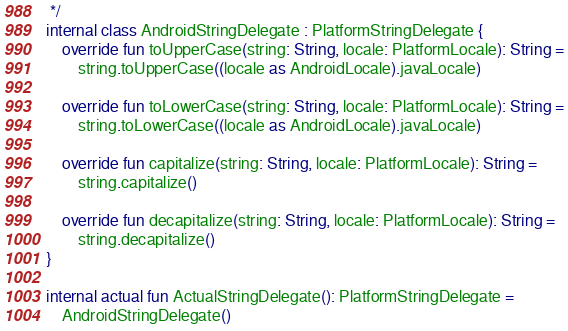<code> <loc_0><loc_0><loc_500><loc_500><_Kotlin_> */
internal class AndroidStringDelegate : PlatformStringDelegate {
    override fun toUpperCase(string: String, locale: PlatformLocale): String =
        string.toUpperCase((locale as AndroidLocale).javaLocale)

    override fun toLowerCase(string: String, locale: PlatformLocale): String =
        string.toLowerCase((locale as AndroidLocale).javaLocale)

    override fun capitalize(string: String, locale: PlatformLocale): String =
        string.capitalize()

    override fun decapitalize(string: String, locale: PlatformLocale): String =
        string.decapitalize()
}

internal actual fun ActualStringDelegate(): PlatformStringDelegate =
    AndroidStringDelegate()</code> 